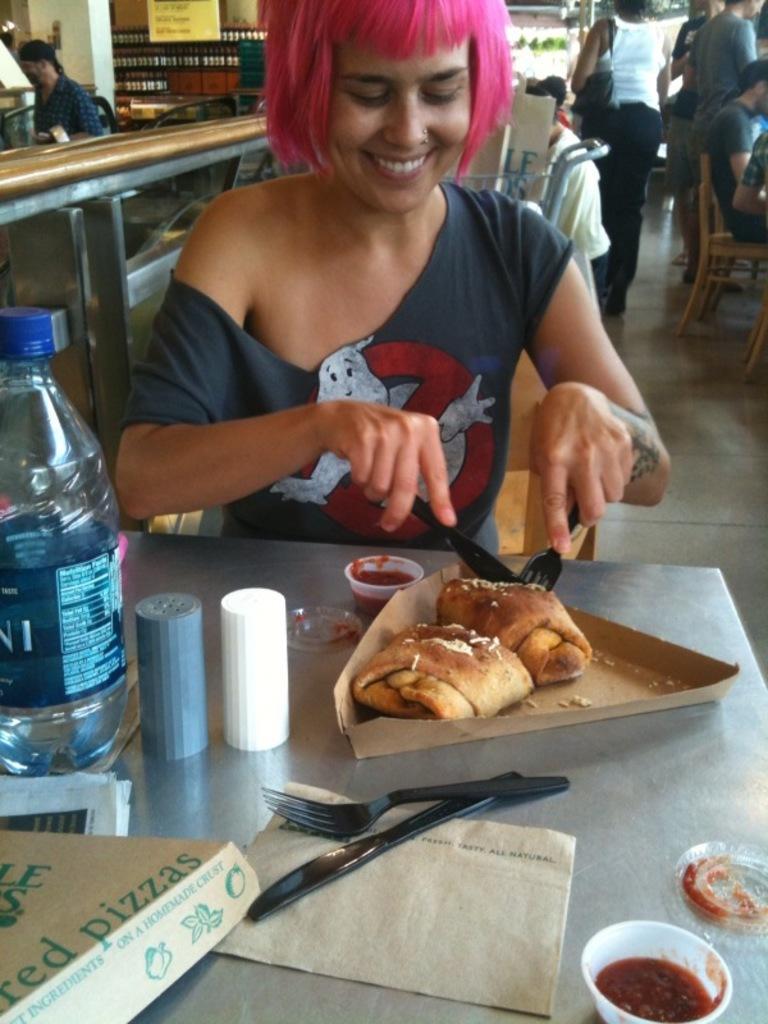Can you describe this image briefly? In this image we can see a girl is smiling and she is wearing grey color t-shirt, she is holding knife and fork in her hand and cutting to some baked item which is in brown color triangle box. In front of her one table is there, on table bottles, fork, knife, fork, cover,container and one bowl is there. Behind her one counter is there and so many people are walking and sitting on chair. 